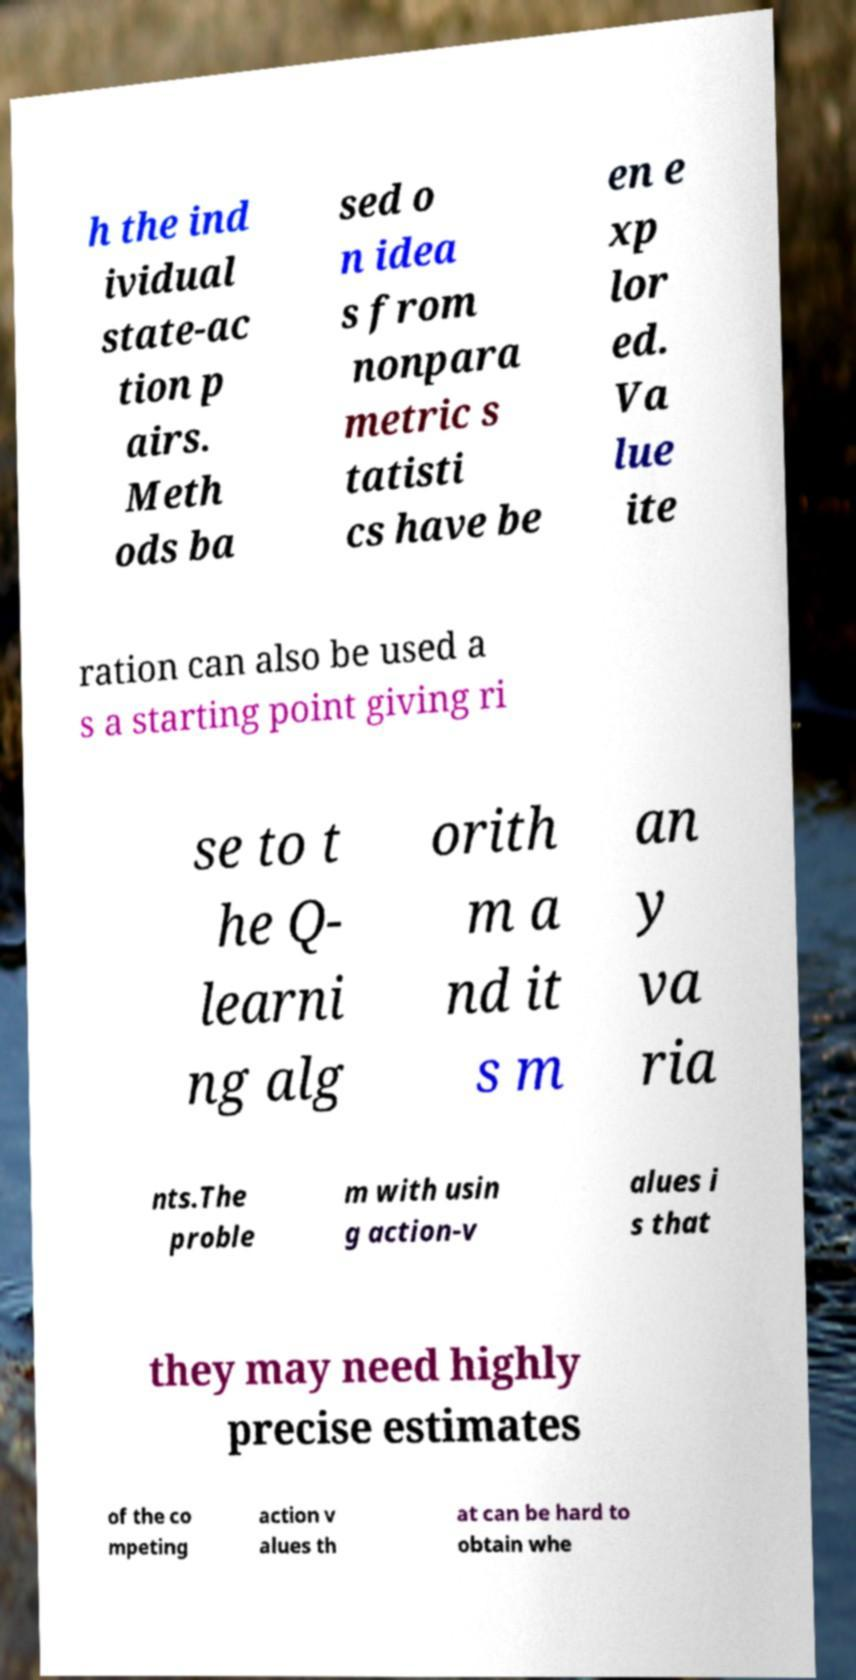For documentation purposes, I need the text within this image transcribed. Could you provide that? h the ind ividual state-ac tion p airs. Meth ods ba sed o n idea s from nonpara metric s tatisti cs have be en e xp lor ed. Va lue ite ration can also be used a s a starting point giving ri se to t he Q- learni ng alg orith m a nd it s m an y va ria nts.The proble m with usin g action-v alues i s that they may need highly precise estimates of the co mpeting action v alues th at can be hard to obtain whe 